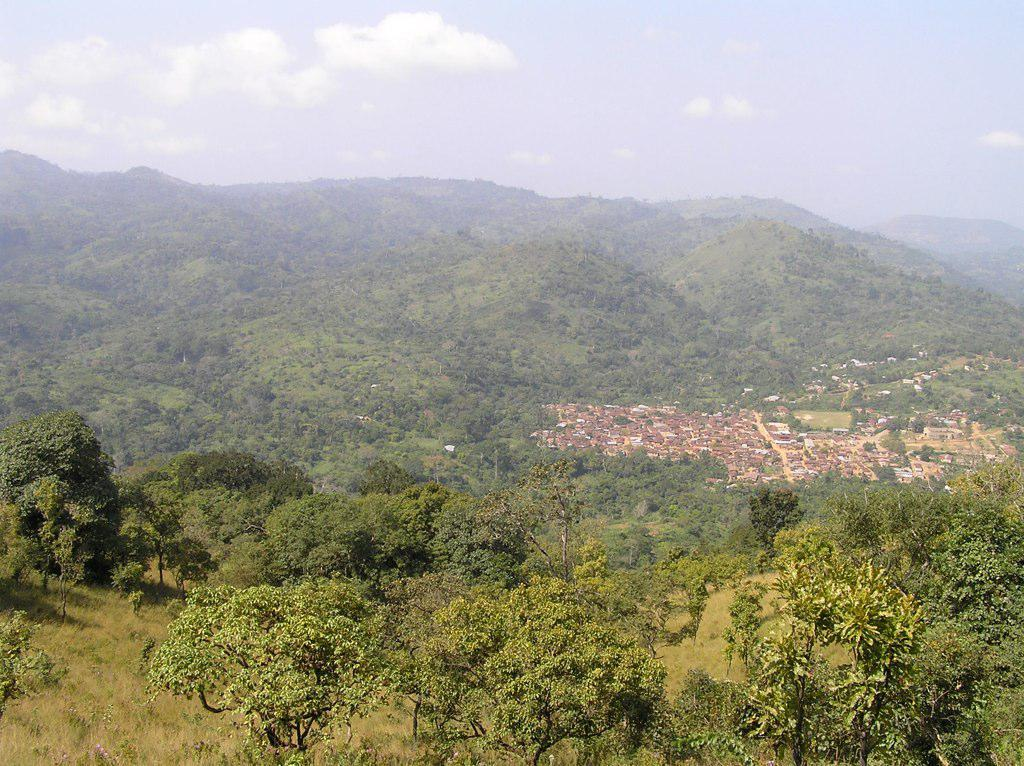What type of natural elements can be seen in the image? There are trees and hills visible in the image. What part of the natural environment is visible in the image? The sky is visible in the image. What type of structures are present in the image? There are sheds in the image. What type of camp can be seen in the image? There is no camp present in the image; it features trees, hills, the sky, and sheds. 